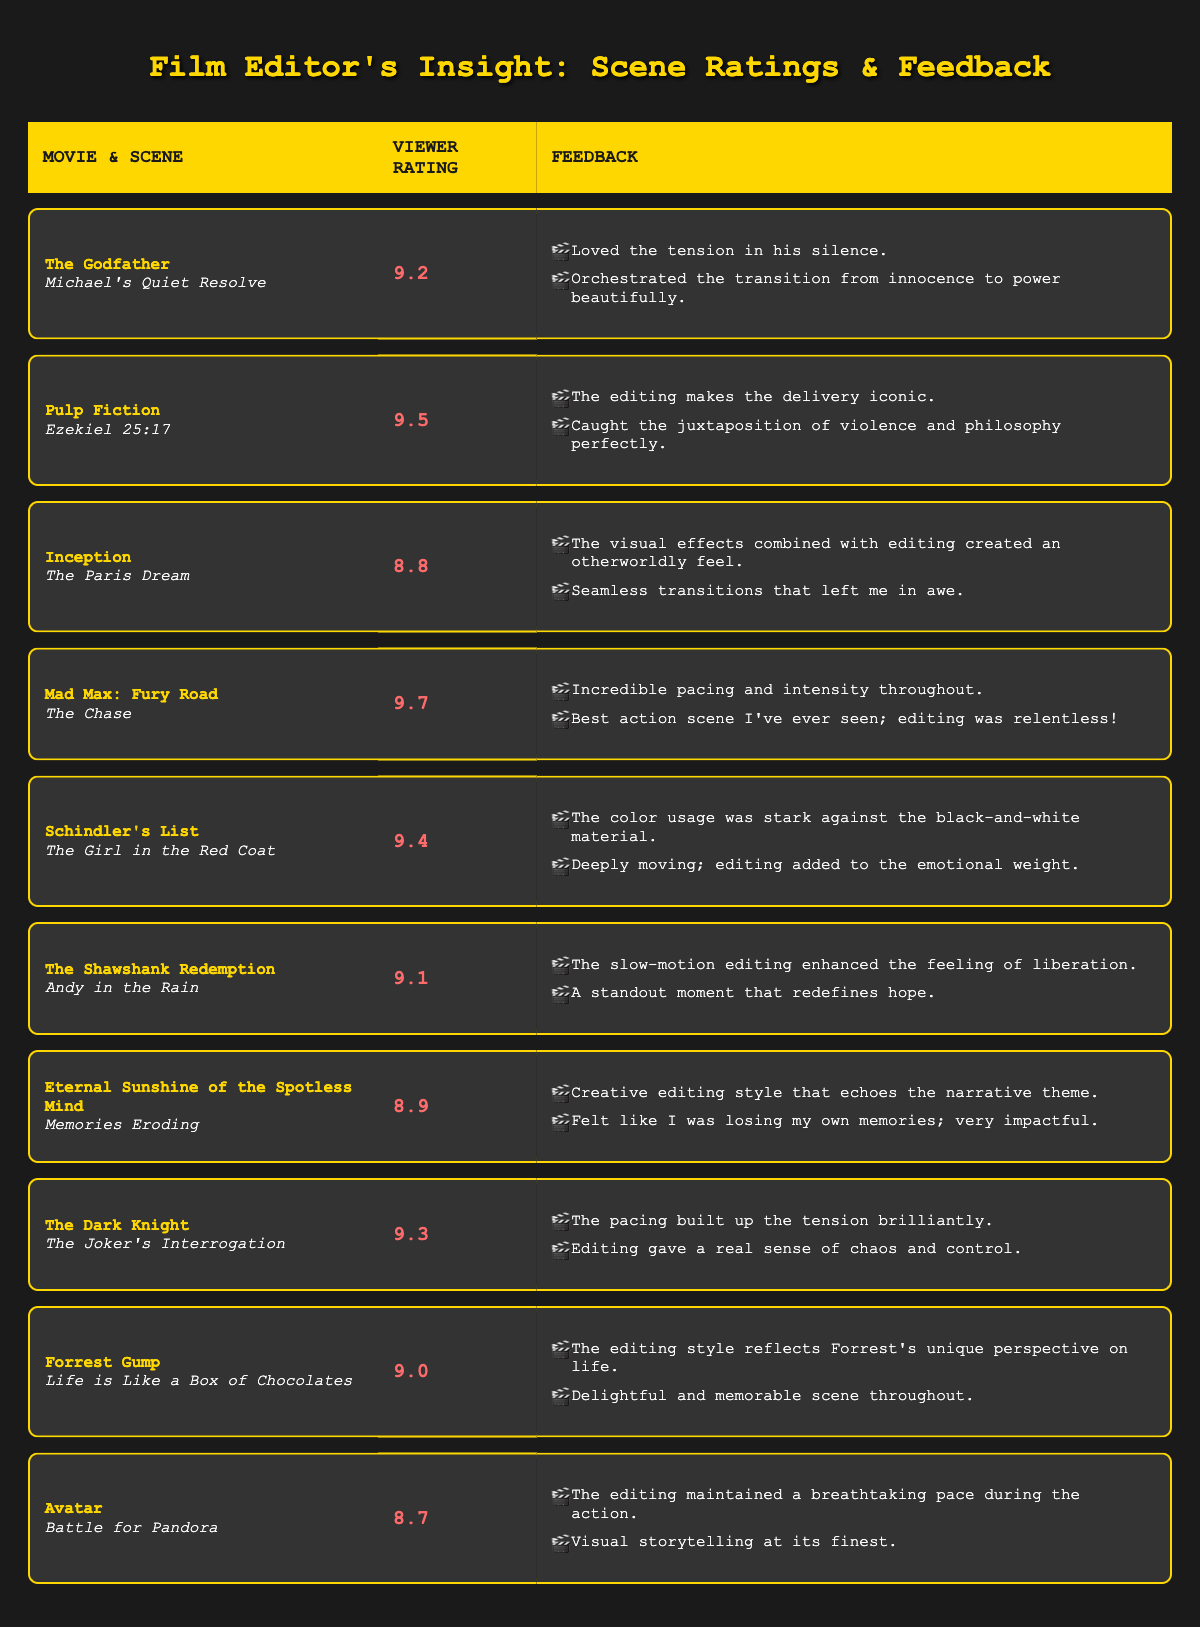What is the highest viewer rating among the edited scenes? The table lists viewer ratings for each scene. Scanning through the ratings, "Mad Max: Fury Road" has the highest rating of 9.7.
Answer: 9.7 Which movie has a scene rated 9.4? By examining the table, the movie "Schindler's List" has the scene "The Girl in the Red Coat," which is rated 9.4.
Answer: Schindler's List Is the viewer rating for "Inception" greater than that of "Avatar"? The rating for "Inception" is 8.8, and for "Avatar," it is 8.7. Since 8.8 is greater than 8.7, the statement is true.
Answer: Yes What is the average viewer rating of the scenes from "The Dark Knight" and "Pulp Fiction"? The viewer rating for "The Dark Knight" is 9.3, and the rating for "Pulp Fiction" is 9.5. Adding them together gives 9.3 + 9.5 = 18.8. Dividing by 2 gives an average rating of 18.8 / 2 = 9.4.
Answer: 9.4 How many feedback comments indicate positive emotions for the scene "Andy in the Rain" in "The Shawshank Redemption"? The feedback for "Andy in the Rain" includes two comments: one about the slow-motion enhancing liberation and another re-defining hope, both suggesting positive emotions. Thus, there are 2 positive comments.
Answer: 2 Which edited scene has the most impactful feedback? Feedback is subjective, but "Mad Max: Fury Road" has a viewer comment saying, "Best action scene I've ever seen; editing was relentless!" This strong expression indicates significant impact. However, the question may vary based on personal interpretation.
Answer: Mad Max: Fury Road Are there any scenes with a viewer rating below 9.0? The table shows several ratings below 9.0, such as "Inception" at 8.8, "Eternal Sunshine of the Spotless Mind" at 8.9, and "Avatar" at 8.7, confirming the statement is true.
Answer: Yes What is the total number of scenes listed in the table? The table presents a total of 10 edited scenes from various movies, thus the total number is 10.
Answer: 10 What is the difference between the highest and lowest viewer ratings in the table? The highest rating is 9.7 (Mad Max: Fury Road), and the lowest rating is 8.7 (Avatar). The difference is 9.7 - 8.7 = 1.0.
Answer: 1.0 